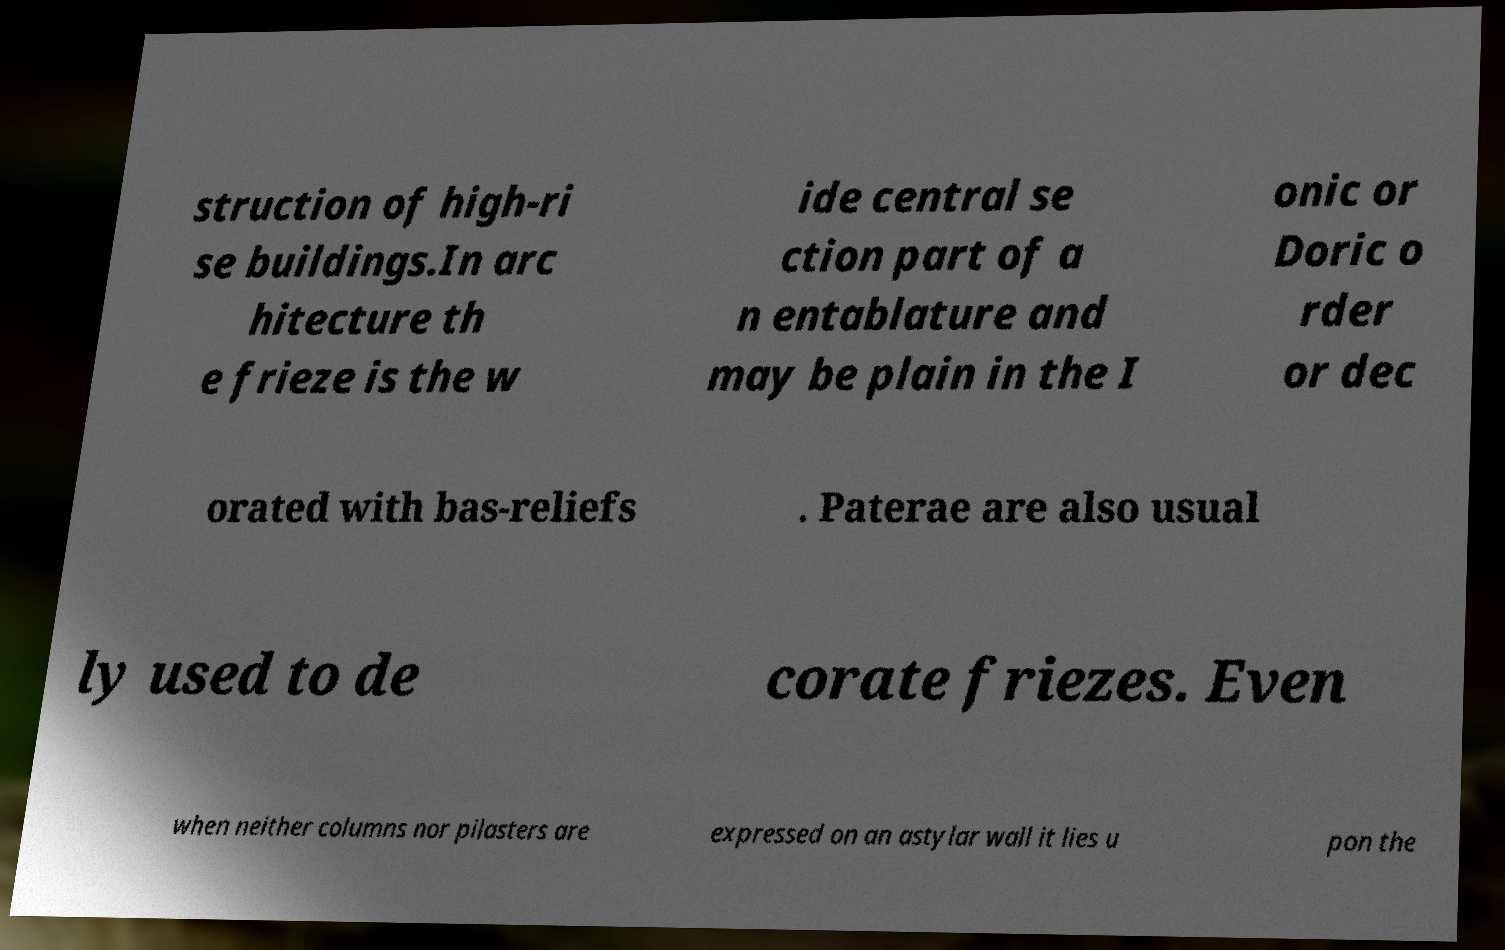There's text embedded in this image that I need extracted. Can you transcribe it verbatim? struction of high-ri se buildings.In arc hitecture th e frieze is the w ide central se ction part of a n entablature and may be plain in the I onic or Doric o rder or dec orated with bas-reliefs . Paterae are also usual ly used to de corate friezes. Even when neither columns nor pilasters are expressed on an astylar wall it lies u pon the 